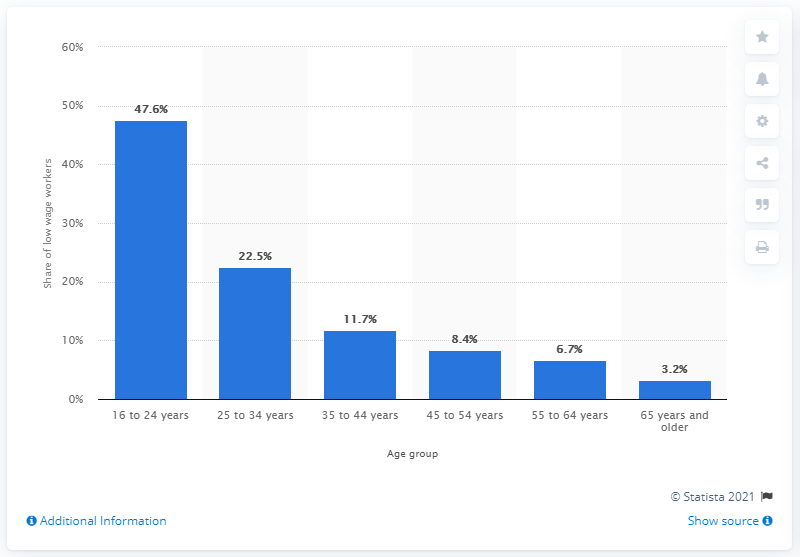Indicate a few pertinent items in this graphic. In 2020, 47.6% of wage and salary workers were aged between 16 and 24. 